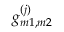<formula> <loc_0><loc_0><loc_500><loc_500>g _ { m 1 , m 2 } ^ { ( j ) }</formula> 